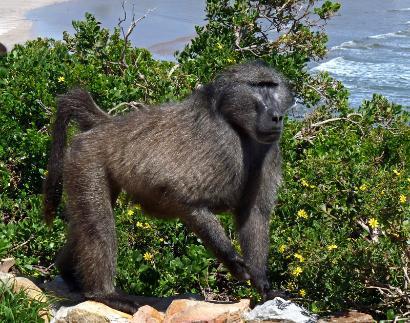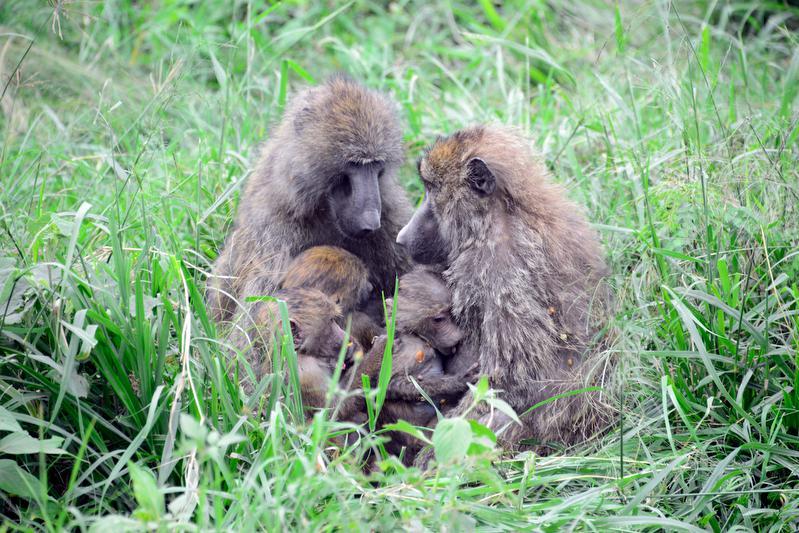The first image is the image on the left, the second image is the image on the right. Analyze the images presented: Is the assertion "All baboons are pictured in the branches of trees, and baboons of different ages are included in the combined images." valid? Answer yes or no. No. The first image is the image on the left, the second image is the image on the right. Considering the images on both sides, is "The monkeys in each of the images are sitting in the trees." valid? Answer yes or no. No. 